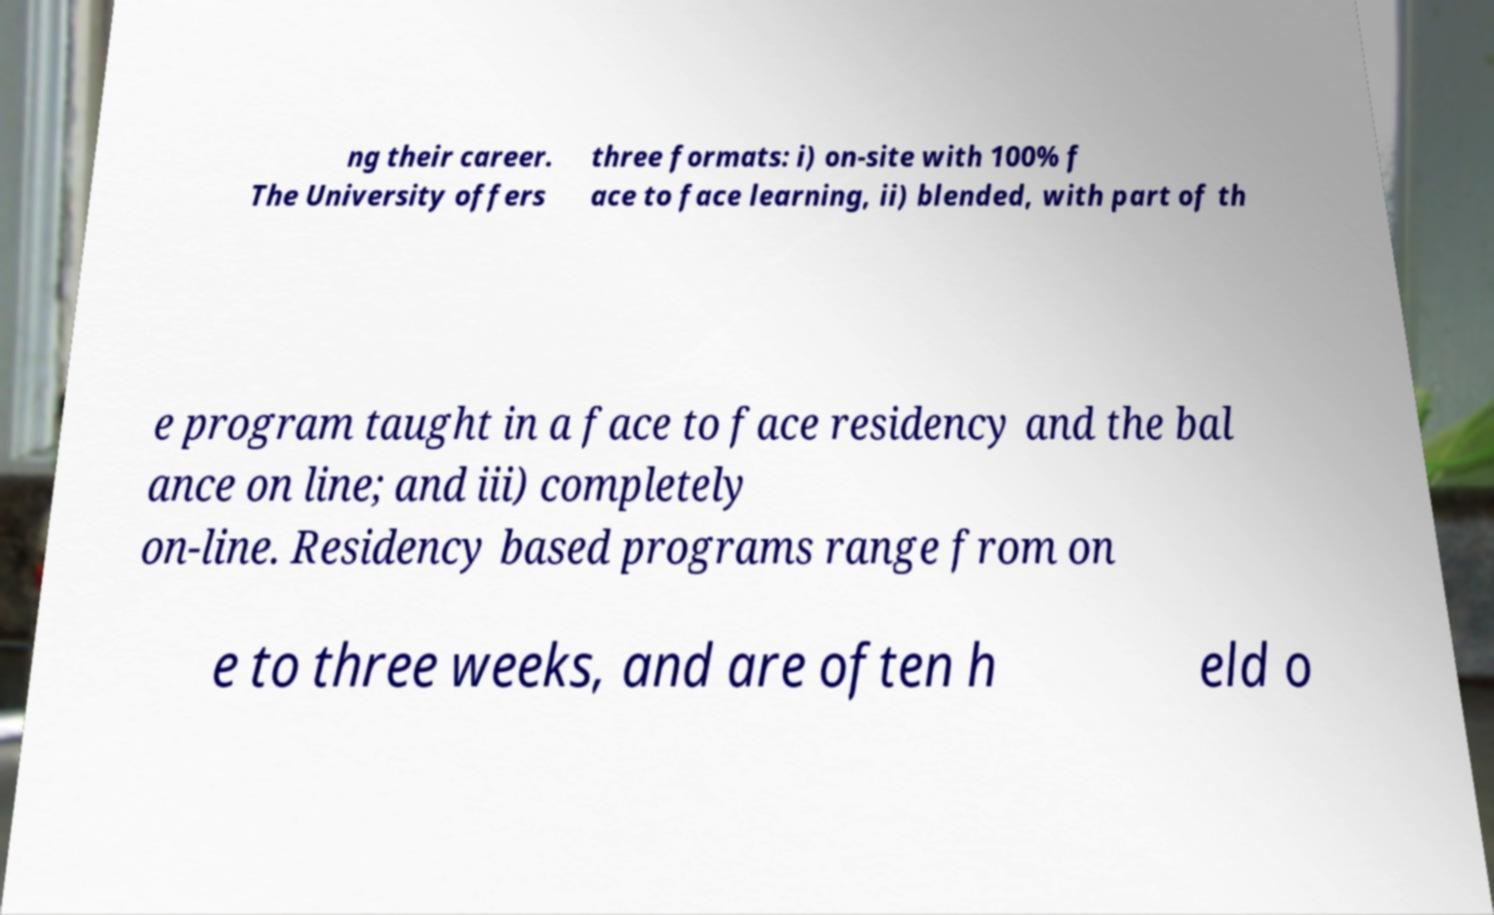Please identify and transcribe the text found in this image. ng their career. The University offers three formats: i) on-site with 100% f ace to face learning, ii) blended, with part of th e program taught in a face to face residency and the bal ance on line; and iii) completely on-line. Residency based programs range from on e to three weeks, and are often h eld o 